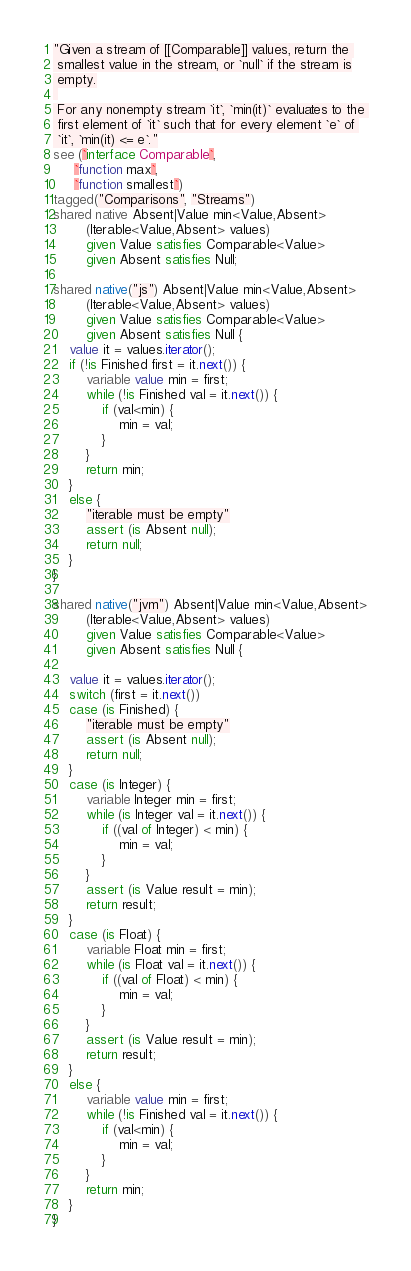Convert code to text. <code><loc_0><loc_0><loc_500><loc_500><_Ceylon_>"Given a stream of [[Comparable]] values, return the 
 smallest value in the stream, or `null` if the stream is
 empty.
 
 For any nonempty stream `it`, `min(it)` evaluates to the 
 first element of `it` such that for every element `e` of 
 `it`, `min(it) <= e`."
see (`interface Comparable`, 
     `function max`,
     `function smallest`)
tagged("Comparisons", "Streams")
shared native Absent|Value min<Value,Absent>
        (Iterable<Value,Absent> values) 
        given Value satisfies Comparable<Value>
        given Absent satisfies Null;

shared native("js") Absent|Value min<Value,Absent>
        (Iterable<Value,Absent> values) 
        given Value satisfies Comparable<Value>
        given Absent satisfies Null {
    value it = values.iterator();
    if (!is Finished first = it.next()) {
        variable value min = first;
        while (!is Finished val = it.next()) {
            if (val<min) {
                min = val;
            }
        }
        return min;
    }
    else {
        "iterable must be empty"
        assert (is Absent null);
        return null;
    }
}

shared native("jvm") Absent|Value min<Value,Absent>
        (Iterable<Value,Absent> values)
        given Value satisfies Comparable<Value>
        given Absent satisfies Null {
    
    value it = values.iterator();
    switch (first = it.next())
    case (is Finished) {
        "iterable must be empty"
        assert (is Absent null);
        return null;
    }
    case (is Integer) {
        variable Integer min = first;
        while (is Integer val = it.next()) {
            if ((val of Integer) < min) {
                min = val;
            }
        }
        assert (is Value result = min);
        return result;
    }
    case (is Float) {
        variable Float min = first;
        while (is Float val = it.next()) {
            if ((val of Float) < min) {
                min = val;
            }
        }
        assert (is Value result = min);
        return result;
    }
    else {
        variable value min = first;
        while (!is Finished val = it.next()) {
            if (val<min) {
                min = val;
            }
        }
        return min;
    }
}</code> 